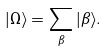Convert formula to latex. <formula><loc_0><loc_0><loc_500><loc_500>| \Omega \rangle = \sum _ { \beta } | \beta \rangle .</formula> 